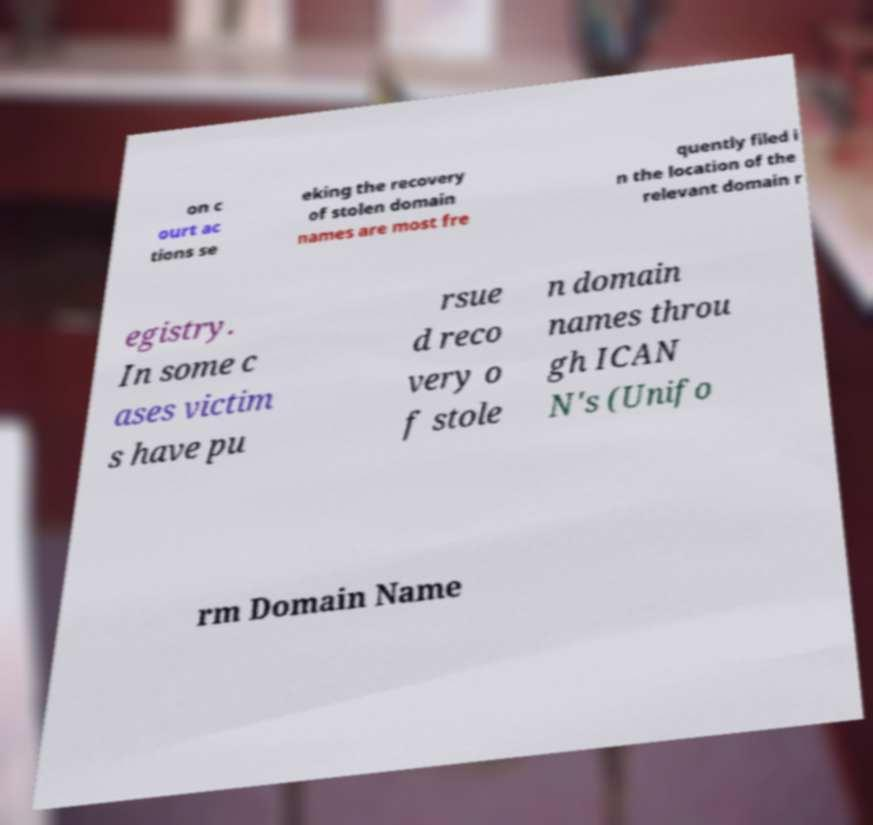Could you assist in decoding the text presented in this image and type it out clearly? on c ourt ac tions se eking the recovery of stolen domain names are most fre quently filed i n the location of the relevant domain r egistry. In some c ases victim s have pu rsue d reco very o f stole n domain names throu gh ICAN N's (Unifo rm Domain Name 